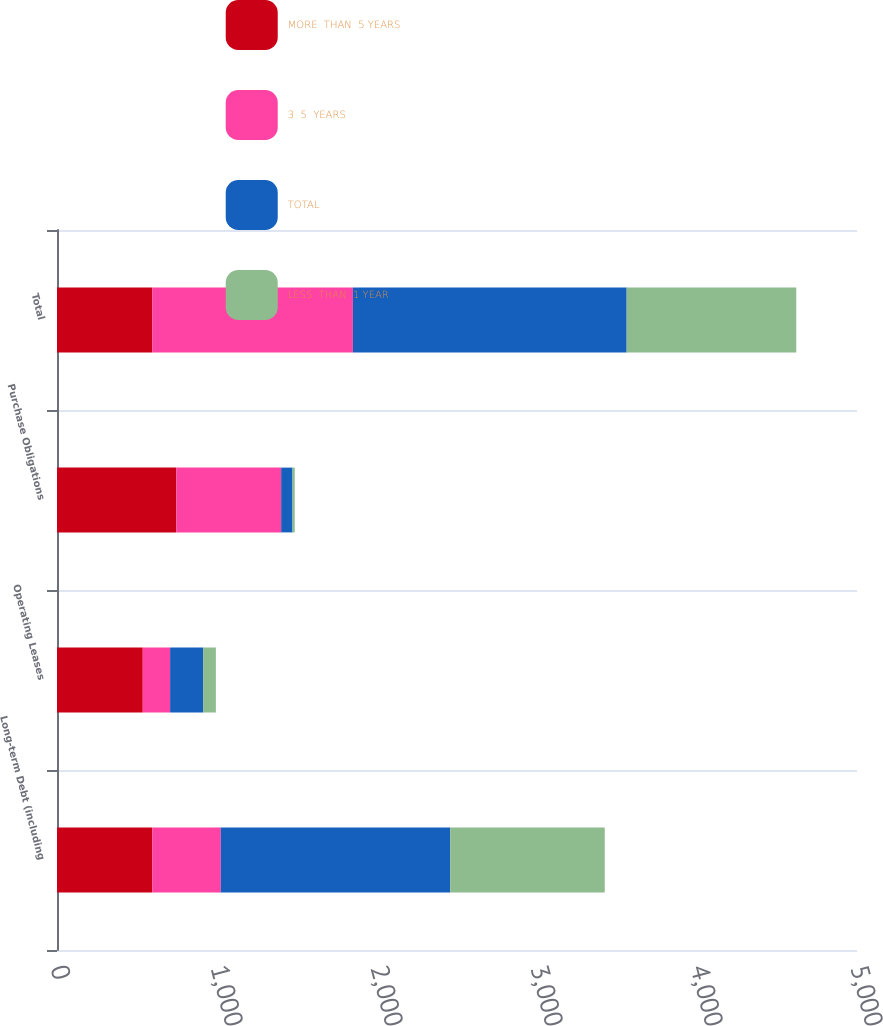<chart> <loc_0><loc_0><loc_500><loc_500><stacked_bar_chart><ecel><fcel>Long-term Debt (including<fcel>Operating Leases<fcel>Purchase Obligations<fcel>Total<nl><fcel>MORE  THAN  5 YEARS<fcel>595.5<fcel>536<fcel>746<fcel>595.5<nl><fcel>3  5  YEARS<fcel>428<fcel>171<fcel>655<fcel>1254<nl><fcel>TOTAL<fcel>1434<fcel>206<fcel>71<fcel>1711<nl><fcel>LESS  THAN  1 YEAR<fcel>966<fcel>80<fcel>14<fcel>1060<nl></chart> 